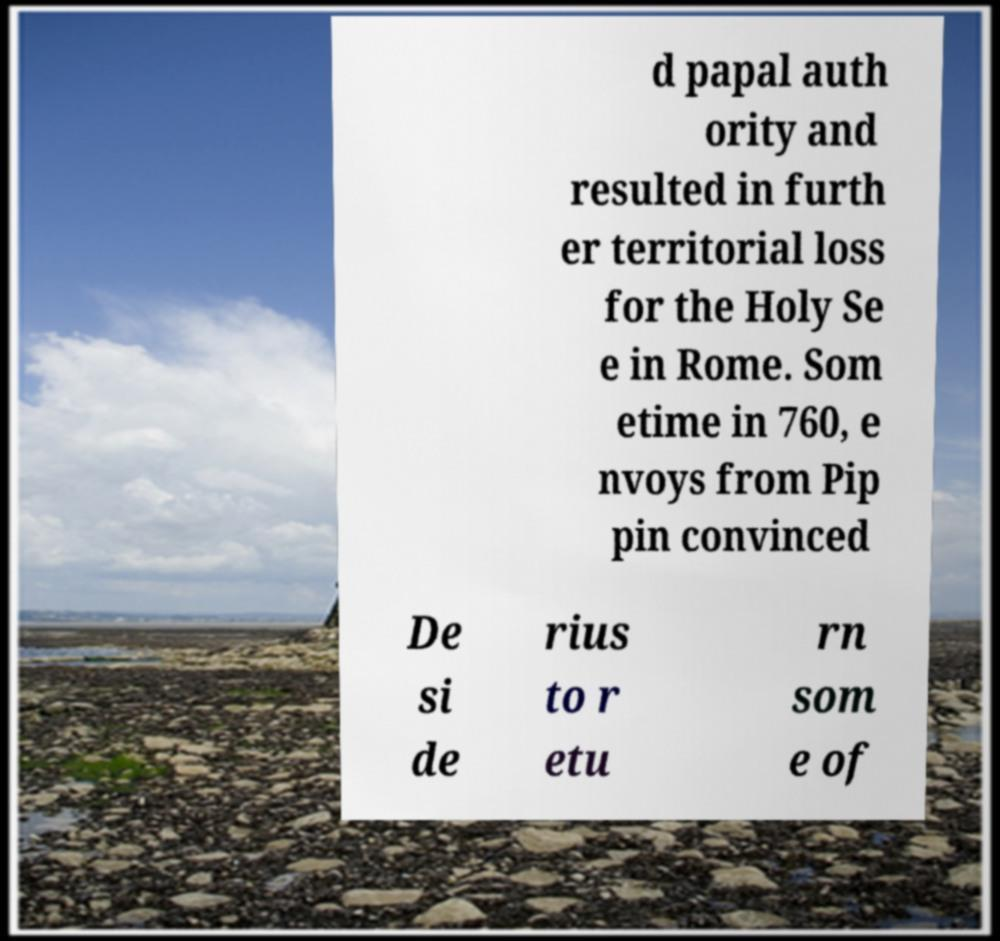Could you extract and type out the text from this image? d papal auth ority and resulted in furth er territorial loss for the Holy Se e in Rome. Som etime in 760, e nvoys from Pip pin convinced De si de rius to r etu rn som e of 